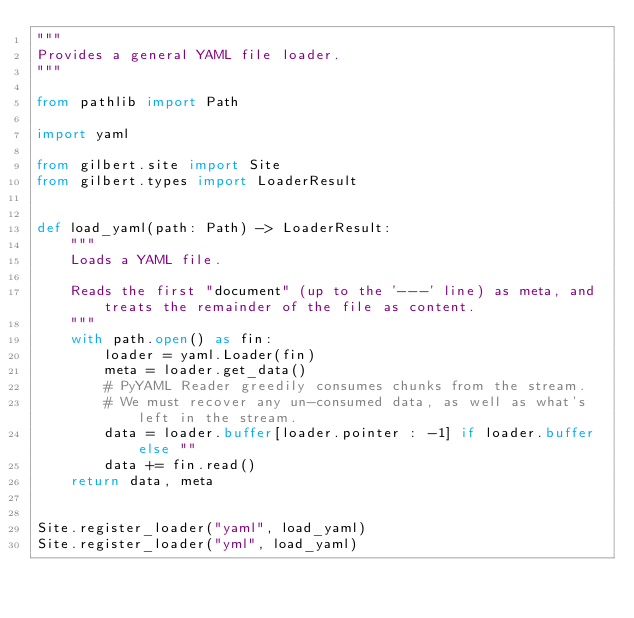Convert code to text. <code><loc_0><loc_0><loc_500><loc_500><_Python_>"""
Provides a general YAML file loader.
"""

from pathlib import Path

import yaml

from gilbert.site import Site
from gilbert.types import LoaderResult


def load_yaml(path: Path) -> LoaderResult:
    """
    Loads a YAML file.

    Reads the first "document" (up to the '---' line) as meta, and treats the remainder of the file as content.
    """
    with path.open() as fin:
        loader = yaml.Loader(fin)
        meta = loader.get_data()
        # PyYAML Reader greedily consumes chunks from the stream.
        # We must recover any un-consumed data, as well as what's left in the stream.
        data = loader.buffer[loader.pointer : -1] if loader.buffer else ""
        data += fin.read()
    return data, meta


Site.register_loader("yaml", load_yaml)
Site.register_loader("yml", load_yaml)
</code> 